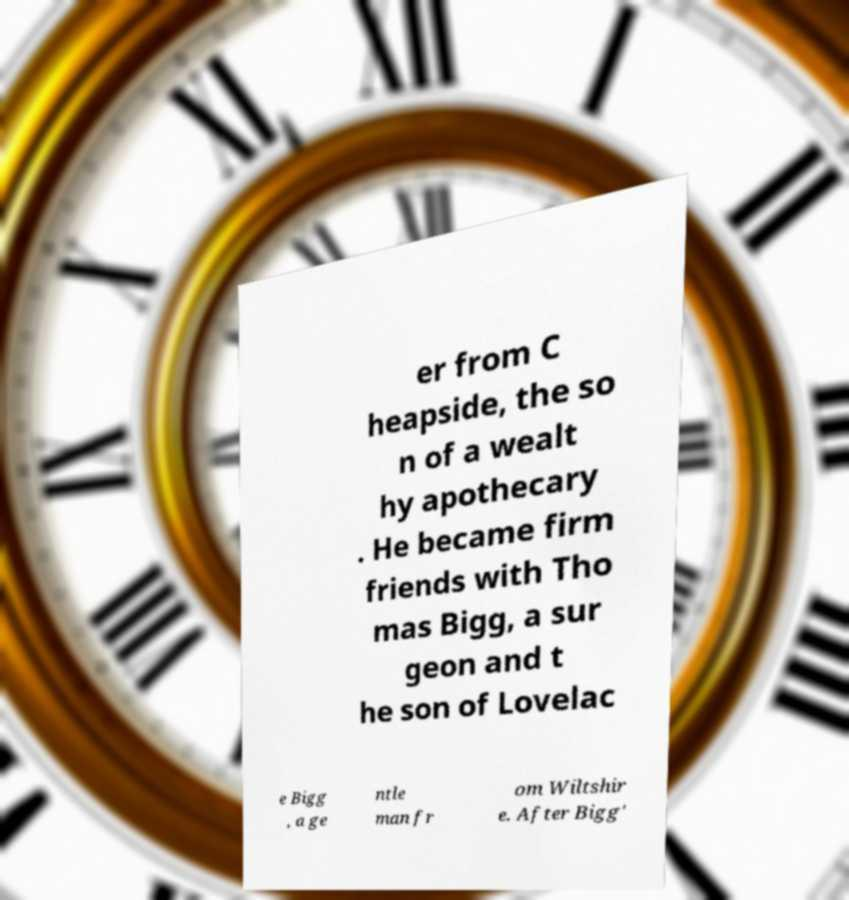Please identify and transcribe the text found in this image. er from C heapside, the so n of a wealt hy apothecary . He became firm friends with Tho mas Bigg, a sur geon and t he son of Lovelac e Bigg , a ge ntle man fr om Wiltshir e. After Bigg' 